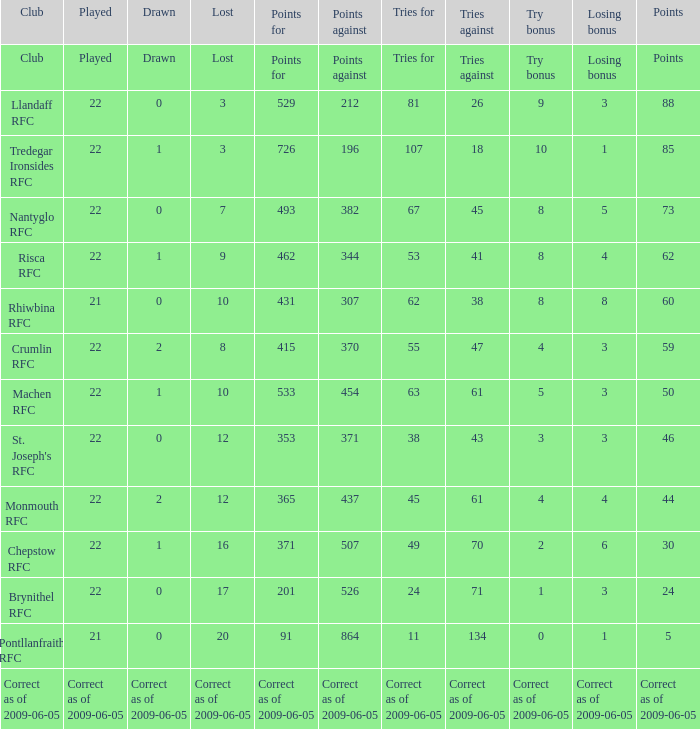If the losing bonus was 6, what is the tries for? 49.0. 